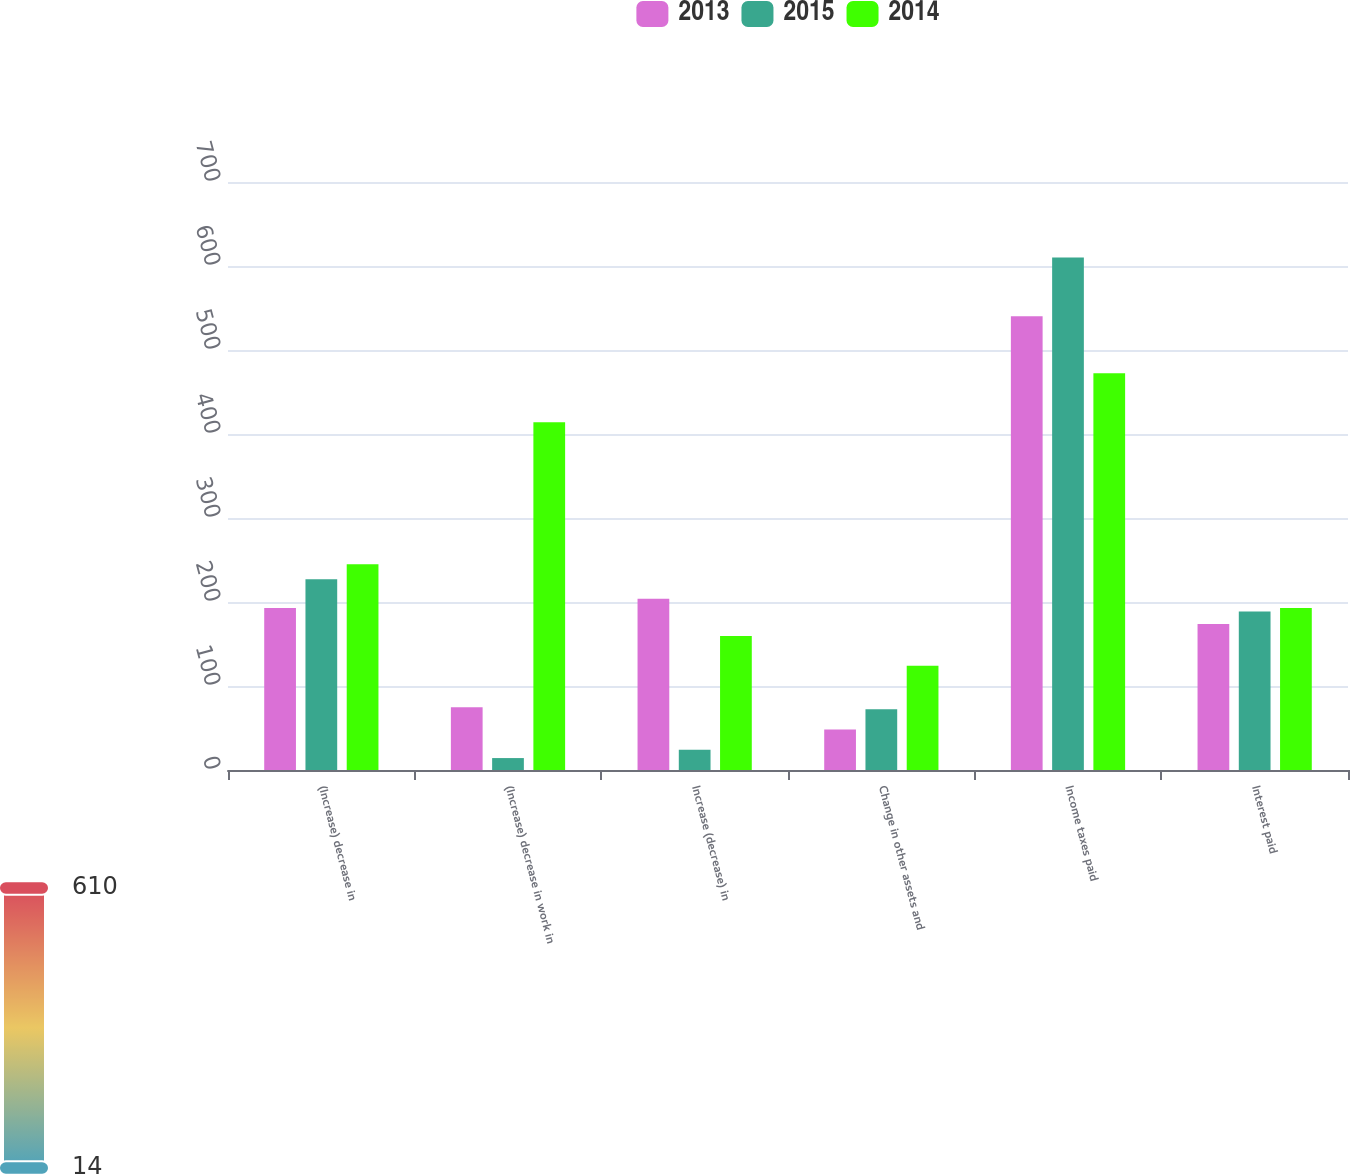<chart> <loc_0><loc_0><loc_500><loc_500><stacked_bar_chart><ecel><fcel>(Increase) decrease in<fcel>(Increase) decrease in work in<fcel>Increase (decrease) in<fcel>Change in other assets and<fcel>Income taxes paid<fcel>Interest paid<nl><fcel>2013<fcel>192.8<fcel>74.7<fcel>203.9<fcel>48.3<fcel>540.1<fcel>173.9<nl><fcel>2015<fcel>227.1<fcel>14.2<fcel>24<fcel>72.2<fcel>610.1<fcel>188.6<nl><fcel>2014<fcel>244.8<fcel>413.9<fcel>159.6<fcel>124.2<fcel>472.4<fcel>192.8<nl></chart> 